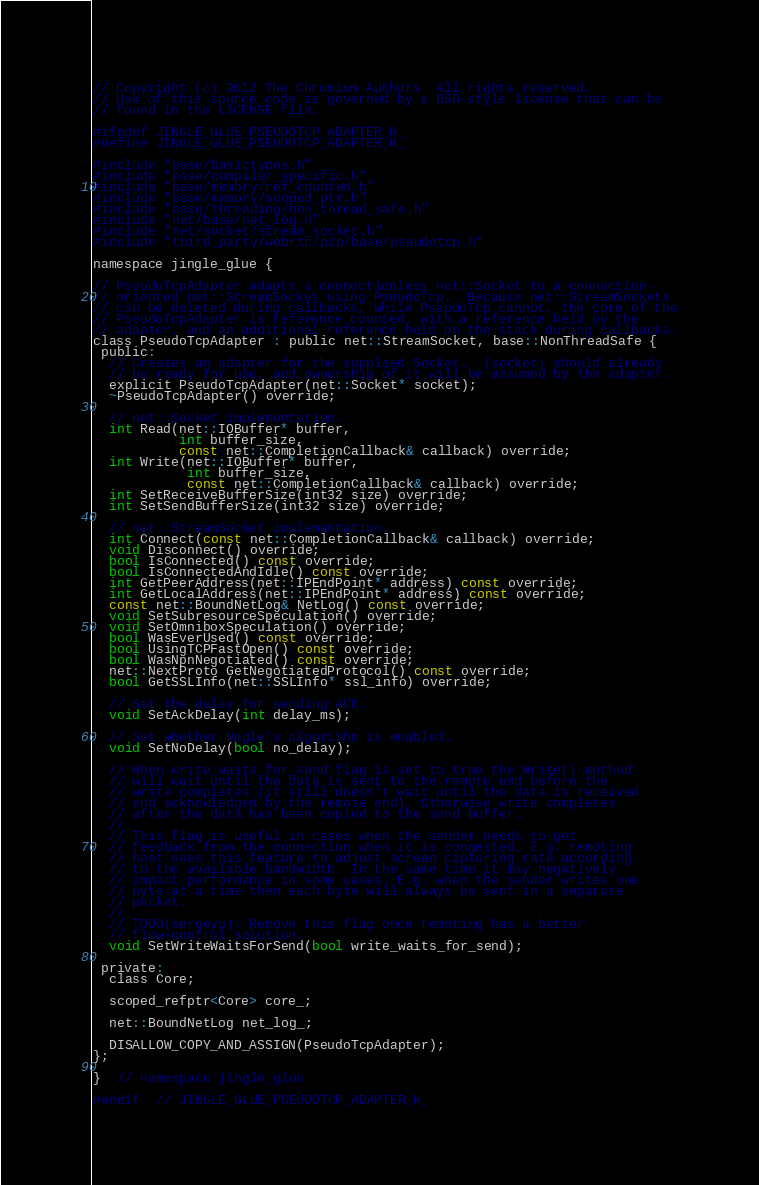<code> <loc_0><loc_0><loc_500><loc_500><_C_>// Copyright (c) 2012 The Chromium Authors. All rights reserved.
// Use of this source code is governed by a BSD-style license that can be
// found in the LICENSE file.

#ifndef JINGLE_GLUE_PSEUDOTCP_ADAPTER_H_
#define JINGLE_GLUE_PSEUDOTCP_ADAPTER_H_

#include "base/basictypes.h"
#include "base/compiler_specific.h"
#include "base/memory/ref_counted.h"
#include "base/memory/scoped_ptr.h"
#include "base/threading/non_thread_safe.h"
#include "net/base/net_log.h"
#include "net/socket/stream_socket.h"
#include "third_party/webrtc/p2p/base/pseudotcp.h"

namespace jingle_glue {

// PseudoTcpAdapter adapts a connectionless net::Socket to a connection-
// oriented net::StreamSocket using PseudoTcp.  Because net::StreamSockets
// can be deleted during callbacks, while PseudoTcp cannot, the core of the
// PseudoTcpAdapter is reference counted, with a reference held by the
// adapter, and an additional reference held on the stack during callbacks.
class PseudoTcpAdapter : public net::StreamSocket, base::NonThreadSafe {
 public:
  // Creates an adapter for the supplied Socket.  |socket| should already
  // be ready for use, and ownership of it will be assumed by the adapter.
  explicit PseudoTcpAdapter(net::Socket* socket);
  ~PseudoTcpAdapter() override;

  // net::Socket implementation.
  int Read(net::IOBuffer* buffer,
           int buffer_size,
           const net::CompletionCallback& callback) override;
  int Write(net::IOBuffer* buffer,
            int buffer_size,
            const net::CompletionCallback& callback) override;
  int SetReceiveBufferSize(int32 size) override;
  int SetSendBufferSize(int32 size) override;

  // net::StreamSocket implementation.
  int Connect(const net::CompletionCallback& callback) override;
  void Disconnect() override;
  bool IsConnected() const override;
  bool IsConnectedAndIdle() const override;
  int GetPeerAddress(net::IPEndPoint* address) const override;
  int GetLocalAddress(net::IPEndPoint* address) const override;
  const net::BoundNetLog& NetLog() const override;
  void SetSubresourceSpeculation() override;
  void SetOmniboxSpeculation() override;
  bool WasEverUsed() const override;
  bool UsingTCPFastOpen() const override;
  bool WasNpnNegotiated() const override;
  net::NextProto GetNegotiatedProtocol() const override;
  bool GetSSLInfo(net::SSLInfo* ssl_info) override;

  // Set the delay for sending ACK.
  void SetAckDelay(int delay_ms);

  // Set whether Nagle's algorithm is enabled.
  void SetNoDelay(bool no_delay);

  // When write_waits_for_send flag is set to true the Write() method
  // will wait until the data is sent to the remote end before the
  // write completes (it still doesn't wait until the data is received
  // and acknowledged by the remote end). Otherwise write completes
  // after the data has been copied to the send buffer.
  //
  // This flag is useful in cases when the sender needs to get
  // feedback from the connection when it is congested. E.g. remoting
  // host uses this feature to adjust screen capturing rate according
  // to the available bandwidth. In the same time it may negatively
  // impact performance in some cases. E.g. when the sender writes one
  // byte at a time then each byte will always be sent in a separate
  // packet.
  //
  // TODO(sergeyu): Remove this flag once remoting has a better
  // flow-control solution.
  void SetWriteWaitsForSend(bool write_waits_for_send);

 private:
  class Core;

  scoped_refptr<Core> core_;

  net::BoundNetLog net_log_;

  DISALLOW_COPY_AND_ASSIGN(PseudoTcpAdapter);
};

}  // namespace jingle_glue

#endif  // JINGLE_GLUE_PSEUDOTCP_ADAPTER_H_
</code> 